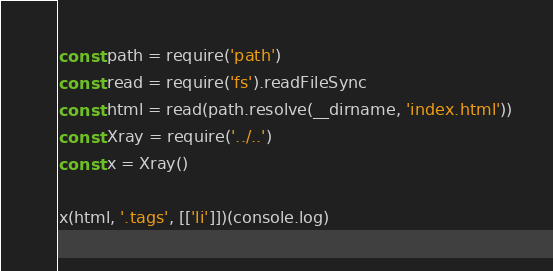<code> <loc_0><loc_0><loc_500><loc_500><_JavaScript_>const path = require('path')
const read = require('fs').readFileSync
const html = read(path.resolve(__dirname, 'index.html'))
const Xray = require('../..')
const x = Xray()

x(html, '.tags', [['li']])(console.log)
</code> 